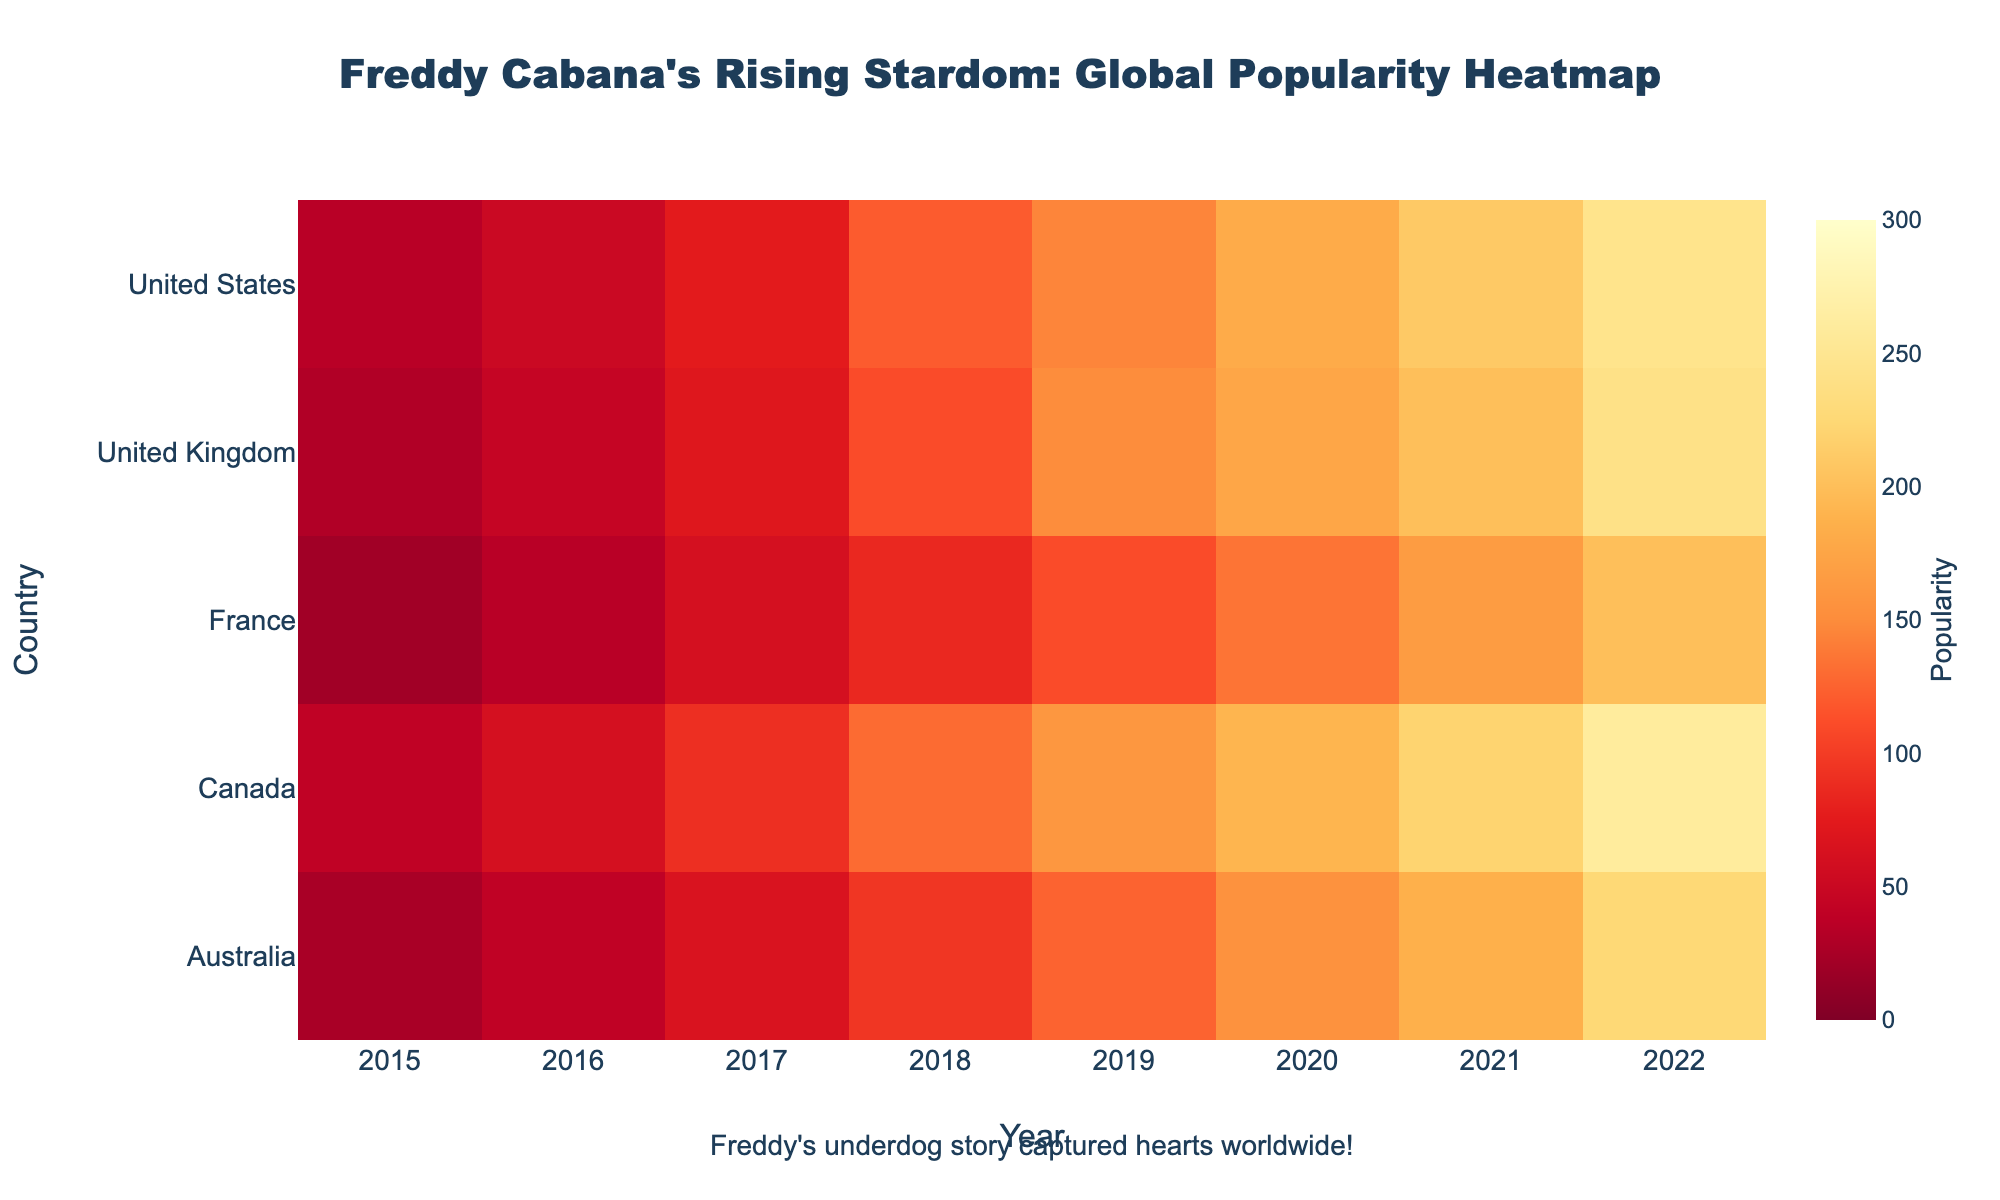What is the title of the heatmap? The title is located at the top center of the heatmap; it reads: "Freddy Cabana's Rising Stardom: Global Popularity Heatmap"
Answer: Freddy Cabana's Rising Stardom: Global Popularity Heatmap During which year did Freddy Cabana's popularity in the United States first exceed 100? By observing the color gradient and the labels, in 2018, the popularity in the United States exceeded 100, going from a value of 75 in 2017 to 120 in 2018
Answer: 2018 Which country shows the highest popularity for Freddy Cabana in 2022? By comparing the color intensity in the year 2022 across all rows, Canada shows the darkest shade, indicating the highest popularity
Answer: Canada How did Freddy Cabana's popularity change in France from 2015 to 2022? Observing the heatmap's color gradient for France from 2015 to 2022, it gradually changes from lighter to darker shades, indicating a consistent increase. It went from 20 in 2015 to 200 in 2022
Answer: Increased What is the average popularity of Freddy Cabana in Australia from 2015 to 2022? For Australia, sum the popularity values from 2015 to 2022: 25 + 40 + 65 + 95 + 125 + 155 + 185 + 225. Average is the sum divided by 8 years: (25 + 40 + 65 + 95 + 125 + 155 + 185 + 225) / 8 = 115
Answer: 115 Which two countries had the closest popularity scores in 2019, and what were those scores? Looking at the heatmap for the year 2019, the popularity scores for Australia and France were 125 and 110 respectively, which are the closest compared to other countries' figures
Answer: Australia (125) and France (110) By what percentage did Freddy Cabana's popularity grow in the United Kingdom from 2017 to 2020? From 70 in 2017 to 175 in 2020: Growth Percentage = ((175-70)/70)*100 = 150%
Answer: 150% In which year did the popularity in Canada first surpass that of Australia, and how much higher was the value? Comparing the colors for Canada and Australia year by year, in 2017, Canada's value (90) surpassed Australia's (65). The difference is 90 - 65 = 25
Answer: 2017, 25 Which country had the smallest increase in popularity from 2021 to 2022 and what was the increase? Observing the color changes from 2021 to 2022, France had the smallest increase from 165 to 200, an increase of 35. The other countries had higher increases
Answer: France, 35 Comparing 2016 and 2019, which country's popularity saw the most significant increase and by how much? By examining the color changes from 2016 to 2019, the United Kingdom's popularity increased from 45 to 150, which is an increase of 105. Other countries had smaller increases
Answer: United Kingdom, 105 